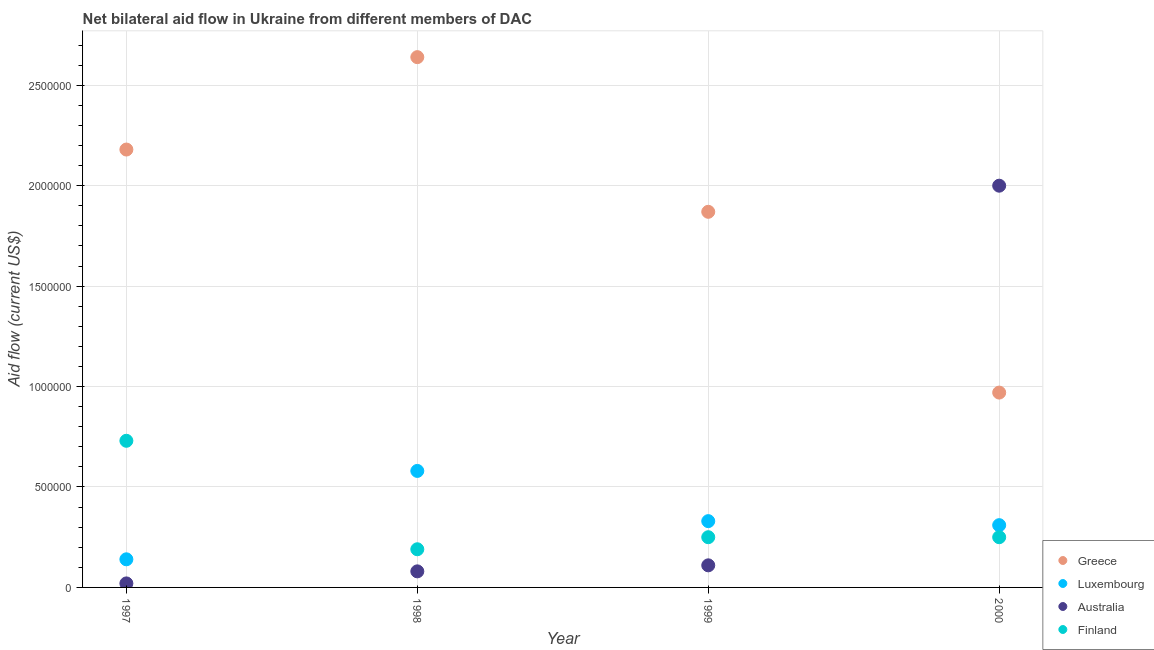Is the number of dotlines equal to the number of legend labels?
Provide a succinct answer. Yes. What is the amount of aid given by finland in 1999?
Provide a succinct answer. 2.50e+05. Across all years, what is the maximum amount of aid given by luxembourg?
Provide a succinct answer. 5.80e+05. Across all years, what is the minimum amount of aid given by luxembourg?
Keep it short and to the point. 1.40e+05. In which year was the amount of aid given by luxembourg minimum?
Offer a terse response. 1997. What is the total amount of aid given by finland in the graph?
Keep it short and to the point. 1.42e+06. What is the difference between the amount of aid given by australia in 1997 and the amount of aid given by greece in 2000?
Offer a terse response. -9.50e+05. What is the average amount of aid given by greece per year?
Your answer should be very brief. 1.92e+06. In the year 1999, what is the difference between the amount of aid given by greece and amount of aid given by luxembourg?
Your answer should be compact. 1.54e+06. What is the ratio of the amount of aid given by greece in 1997 to that in 1998?
Your response must be concise. 0.83. Is the amount of aid given by australia in 1997 less than that in 2000?
Make the answer very short. Yes. Is the difference between the amount of aid given by luxembourg in 1997 and 2000 greater than the difference between the amount of aid given by greece in 1997 and 2000?
Ensure brevity in your answer.  No. What is the difference between the highest and the lowest amount of aid given by greece?
Provide a succinct answer. 1.67e+06. In how many years, is the amount of aid given by finland greater than the average amount of aid given by finland taken over all years?
Your response must be concise. 1. Does the amount of aid given by finland monotonically increase over the years?
Offer a terse response. No. Is the amount of aid given by australia strictly less than the amount of aid given by finland over the years?
Keep it short and to the point. No. How many dotlines are there?
Your response must be concise. 4. How many years are there in the graph?
Offer a very short reply. 4. What is the difference between two consecutive major ticks on the Y-axis?
Give a very brief answer. 5.00e+05. Does the graph contain grids?
Your answer should be compact. Yes. Where does the legend appear in the graph?
Ensure brevity in your answer.  Bottom right. What is the title of the graph?
Make the answer very short. Net bilateral aid flow in Ukraine from different members of DAC. What is the label or title of the X-axis?
Offer a terse response. Year. What is the Aid flow (current US$) of Greece in 1997?
Make the answer very short. 2.18e+06. What is the Aid flow (current US$) of Luxembourg in 1997?
Provide a short and direct response. 1.40e+05. What is the Aid flow (current US$) in Finland in 1997?
Provide a short and direct response. 7.30e+05. What is the Aid flow (current US$) of Greece in 1998?
Give a very brief answer. 2.64e+06. What is the Aid flow (current US$) of Luxembourg in 1998?
Provide a succinct answer. 5.80e+05. What is the Aid flow (current US$) of Greece in 1999?
Your response must be concise. 1.87e+06. What is the Aid flow (current US$) in Luxembourg in 1999?
Provide a short and direct response. 3.30e+05. What is the Aid flow (current US$) in Australia in 1999?
Your response must be concise. 1.10e+05. What is the Aid flow (current US$) of Finland in 1999?
Give a very brief answer. 2.50e+05. What is the Aid flow (current US$) of Greece in 2000?
Your response must be concise. 9.70e+05. What is the Aid flow (current US$) of Australia in 2000?
Your response must be concise. 2.00e+06. Across all years, what is the maximum Aid flow (current US$) of Greece?
Offer a very short reply. 2.64e+06. Across all years, what is the maximum Aid flow (current US$) in Luxembourg?
Provide a short and direct response. 5.80e+05. Across all years, what is the maximum Aid flow (current US$) of Finland?
Your answer should be very brief. 7.30e+05. Across all years, what is the minimum Aid flow (current US$) of Greece?
Keep it short and to the point. 9.70e+05. What is the total Aid flow (current US$) in Greece in the graph?
Your response must be concise. 7.66e+06. What is the total Aid flow (current US$) of Luxembourg in the graph?
Provide a succinct answer. 1.36e+06. What is the total Aid flow (current US$) in Australia in the graph?
Offer a terse response. 2.21e+06. What is the total Aid flow (current US$) in Finland in the graph?
Make the answer very short. 1.42e+06. What is the difference between the Aid flow (current US$) of Greece in 1997 and that in 1998?
Make the answer very short. -4.60e+05. What is the difference between the Aid flow (current US$) of Luxembourg in 1997 and that in 1998?
Make the answer very short. -4.40e+05. What is the difference between the Aid flow (current US$) in Australia in 1997 and that in 1998?
Ensure brevity in your answer.  -6.00e+04. What is the difference between the Aid flow (current US$) in Finland in 1997 and that in 1998?
Your answer should be compact. 5.40e+05. What is the difference between the Aid flow (current US$) of Greece in 1997 and that in 1999?
Offer a very short reply. 3.10e+05. What is the difference between the Aid flow (current US$) in Luxembourg in 1997 and that in 1999?
Make the answer very short. -1.90e+05. What is the difference between the Aid flow (current US$) in Greece in 1997 and that in 2000?
Provide a short and direct response. 1.21e+06. What is the difference between the Aid flow (current US$) in Luxembourg in 1997 and that in 2000?
Offer a terse response. -1.70e+05. What is the difference between the Aid flow (current US$) of Australia in 1997 and that in 2000?
Your answer should be very brief. -1.98e+06. What is the difference between the Aid flow (current US$) of Finland in 1997 and that in 2000?
Give a very brief answer. 4.80e+05. What is the difference between the Aid flow (current US$) of Greece in 1998 and that in 1999?
Provide a short and direct response. 7.70e+05. What is the difference between the Aid flow (current US$) of Luxembourg in 1998 and that in 1999?
Your answer should be very brief. 2.50e+05. What is the difference between the Aid flow (current US$) of Australia in 1998 and that in 1999?
Your response must be concise. -3.00e+04. What is the difference between the Aid flow (current US$) in Greece in 1998 and that in 2000?
Offer a very short reply. 1.67e+06. What is the difference between the Aid flow (current US$) of Luxembourg in 1998 and that in 2000?
Your response must be concise. 2.70e+05. What is the difference between the Aid flow (current US$) of Australia in 1998 and that in 2000?
Keep it short and to the point. -1.92e+06. What is the difference between the Aid flow (current US$) in Greece in 1999 and that in 2000?
Provide a succinct answer. 9.00e+05. What is the difference between the Aid flow (current US$) in Australia in 1999 and that in 2000?
Make the answer very short. -1.89e+06. What is the difference between the Aid flow (current US$) in Greece in 1997 and the Aid flow (current US$) in Luxembourg in 1998?
Provide a short and direct response. 1.60e+06. What is the difference between the Aid flow (current US$) in Greece in 1997 and the Aid flow (current US$) in Australia in 1998?
Your answer should be very brief. 2.10e+06. What is the difference between the Aid flow (current US$) of Greece in 1997 and the Aid flow (current US$) of Finland in 1998?
Your answer should be very brief. 1.99e+06. What is the difference between the Aid flow (current US$) of Luxembourg in 1997 and the Aid flow (current US$) of Finland in 1998?
Provide a succinct answer. -5.00e+04. What is the difference between the Aid flow (current US$) of Australia in 1997 and the Aid flow (current US$) of Finland in 1998?
Your answer should be very brief. -1.70e+05. What is the difference between the Aid flow (current US$) of Greece in 1997 and the Aid flow (current US$) of Luxembourg in 1999?
Offer a terse response. 1.85e+06. What is the difference between the Aid flow (current US$) of Greece in 1997 and the Aid flow (current US$) of Australia in 1999?
Your answer should be compact. 2.07e+06. What is the difference between the Aid flow (current US$) of Greece in 1997 and the Aid flow (current US$) of Finland in 1999?
Provide a succinct answer. 1.93e+06. What is the difference between the Aid flow (current US$) of Luxembourg in 1997 and the Aid flow (current US$) of Finland in 1999?
Offer a very short reply. -1.10e+05. What is the difference between the Aid flow (current US$) in Australia in 1997 and the Aid flow (current US$) in Finland in 1999?
Offer a terse response. -2.30e+05. What is the difference between the Aid flow (current US$) of Greece in 1997 and the Aid flow (current US$) of Luxembourg in 2000?
Provide a succinct answer. 1.87e+06. What is the difference between the Aid flow (current US$) in Greece in 1997 and the Aid flow (current US$) in Finland in 2000?
Make the answer very short. 1.93e+06. What is the difference between the Aid flow (current US$) of Luxembourg in 1997 and the Aid flow (current US$) of Australia in 2000?
Offer a very short reply. -1.86e+06. What is the difference between the Aid flow (current US$) of Greece in 1998 and the Aid flow (current US$) of Luxembourg in 1999?
Make the answer very short. 2.31e+06. What is the difference between the Aid flow (current US$) in Greece in 1998 and the Aid flow (current US$) in Australia in 1999?
Your answer should be very brief. 2.53e+06. What is the difference between the Aid flow (current US$) in Greece in 1998 and the Aid flow (current US$) in Finland in 1999?
Offer a very short reply. 2.39e+06. What is the difference between the Aid flow (current US$) in Luxembourg in 1998 and the Aid flow (current US$) in Finland in 1999?
Your answer should be very brief. 3.30e+05. What is the difference between the Aid flow (current US$) of Australia in 1998 and the Aid flow (current US$) of Finland in 1999?
Offer a terse response. -1.70e+05. What is the difference between the Aid flow (current US$) in Greece in 1998 and the Aid flow (current US$) in Luxembourg in 2000?
Your response must be concise. 2.33e+06. What is the difference between the Aid flow (current US$) of Greece in 1998 and the Aid flow (current US$) of Australia in 2000?
Provide a succinct answer. 6.40e+05. What is the difference between the Aid flow (current US$) in Greece in 1998 and the Aid flow (current US$) in Finland in 2000?
Keep it short and to the point. 2.39e+06. What is the difference between the Aid flow (current US$) in Luxembourg in 1998 and the Aid flow (current US$) in Australia in 2000?
Ensure brevity in your answer.  -1.42e+06. What is the difference between the Aid flow (current US$) in Luxembourg in 1998 and the Aid flow (current US$) in Finland in 2000?
Offer a very short reply. 3.30e+05. What is the difference between the Aid flow (current US$) of Australia in 1998 and the Aid flow (current US$) of Finland in 2000?
Give a very brief answer. -1.70e+05. What is the difference between the Aid flow (current US$) in Greece in 1999 and the Aid flow (current US$) in Luxembourg in 2000?
Your answer should be very brief. 1.56e+06. What is the difference between the Aid flow (current US$) in Greece in 1999 and the Aid flow (current US$) in Australia in 2000?
Give a very brief answer. -1.30e+05. What is the difference between the Aid flow (current US$) of Greece in 1999 and the Aid flow (current US$) of Finland in 2000?
Keep it short and to the point. 1.62e+06. What is the difference between the Aid flow (current US$) in Luxembourg in 1999 and the Aid flow (current US$) in Australia in 2000?
Ensure brevity in your answer.  -1.67e+06. What is the difference between the Aid flow (current US$) of Luxembourg in 1999 and the Aid flow (current US$) of Finland in 2000?
Provide a succinct answer. 8.00e+04. What is the difference between the Aid flow (current US$) of Australia in 1999 and the Aid flow (current US$) of Finland in 2000?
Your answer should be very brief. -1.40e+05. What is the average Aid flow (current US$) of Greece per year?
Ensure brevity in your answer.  1.92e+06. What is the average Aid flow (current US$) in Luxembourg per year?
Make the answer very short. 3.40e+05. What is the average Aid flow (current US$) in Australia per year?
Your answer should be very brief. 5.52e+05. What is the average Aid flow (current US$) in Finland per year?
Provide a succinct answer. 3.55e+05. In the year 1997, what is the difference between the Aid flow (current US$) in Greece and Aid flow (current US$) in Luxembourg?
Ensure brevity in your answer.  2.04e+06. In the year 1997, what is the difference between the Aid flow (current US$) of Greece and Aid flow (current US$) of Australia?
Make the answer very short. 2.16e+06. In the year 1997, what is the difference between the Aid flow (current US$) of Greece and Aid flow (current US$) of Finland?
Give a very brief answer. 1.45e+06. In the year 1997, what is the difference between the Aid flow (current US$) of Luxembourg and Aid flow (current US$) of Finland?
Offer a very short reply. -5.90e+05. In the year 1997, what is the difference between the Aid flow (current US$) of Australia and Aid flow (current US$) of Finland?
Provide a succinct answer. -7.10e+05. In the year 1998, what is the difference between the Aid flow (current US$) of Greece and Aid flow (current US$) of Luxembourg?
Make the answer very short. 2.06e+06. In the year 1998, what is the difference between the Aid flow (current US$) in Greece and Aid flow (current US$) in Australia?
Your response must be concise. 2.56e+06. In the year 1998, what is the difference between the Aid flow (current US$) of Greece and Aid flow (current US$) of Finland?
Give a very brief answer. 2.45e+06. In the year 1998, what is the difference between the Aid flow (current US$) of Luxembourg and Aid flow (current US$) of Australia?
Offer a very short reply. 5.00e+05. In the year 1998, what is the difference between the Aid flow (current US$) of Australia and Aid flow (current US$) of Finland?
Offer a very short reply. -1.10e+05. In the year 1999, what is the difference between the Aid flow (current US$) in Greece and Aid flow (current US$) in Luxembourg?
Provide a succinct answer. 1.54e+06. In the year 1999, what is the difference between the Aid flow (current US$) of Greece and Aid flow (current US$) of Australia?
Your response must be concise. 1.76e+06. In the year 1999, what is the difference between the Aid flow (current US$) in Greece and Aid flow (current US$) in Finland?
Ensure brevity in your answer.  1.62e+06. In the year 1999, what is the difference between the Aid flow (current US$) of Australia and Aid flow (current US$) of Finland?
Your response must be concise. -1.40e+05. In the year 2000, what is the difference between the Aid flow (current US$) of Greece and Aid flow (current US$) of Australia?
Your response must be concise. -1.03e+06. In the year 2000, what is the difference between the Aid flow (current US$) of Greece and Aid flow (current US$) of Finland?
Make the answer very short. 7.20e+05. In the year 2000, what is the difference between the Aid flow (current US$) in Luxembourg and Aid flow (current US$) in Australia?
Offer a very short reply. -1.69e+06. In the year 2000, what is the difference between the Aid flow (current US$) of Australia and Aid flow (current US$) of Finland?
Provide a succinct answer. 1.75e+06. What is the ratio of the Aid flow (current US$) in Greece in 1997 to that in 1998?
Provide a short and direct response. 0.83. What is the ratio of the Aid flow (current US$) in Luxembourg in 1997 to that in 1998?
Keep it short and to the point. 0.24. What is the ratio of the Aid flow (current US$) in Australia in 1997 to that in 1998?
Give a very brief answer. 0.25. What is the ratio of the Aid flow (current US$) of Finland in 1997 to that in 1998?
Keep it short and to the point. 3.84. What is the ratio of the Aid flow (current US$) of Greece in 1997 to that in 1999?
Offer a very short reply. 1.17. What is the ratio of the Aid flow (current US$) of Luxembourg in 1997 to that in 1999?
Make the answer very short. 0.42. What is the ratio of the Aid flow (current US$) in Australia in 1997 to that in 1999?
Keep it short and to the point. 0.18. What is the ratio of the Aid flow (current US$) of Finland in 1997 to that in 1999?
Your response must be concise. 2.92. What is the ratio of the Aid flow (current US$) in Greece in 1997 to that in 2000?
Ensure brevity in your answer.  2.25. What is the ratio of the Aid flow (current US$) of Luxembourg in 1997 to that in 2000?
Your response must be concise. 0.45. What is the ratio of the Aid flow (current US$) of Finland in 1997 to that in 2000?
Ensure brevity in your answer.  2.92. What is the ratio of the Aid flow (current US$) in Greece in 1998 to that in 1999?
Give a very brief answer. 1.41. What is the ratio of the Aid flow (current US$) in Luxembourg in 1998 to that in 1999?
Your answer should be very brief. 1.76. What is the ratio of the Aid flow (current US$) of Australia in 1998 to that in 1999?
Your answer should be very brief. 0.73. What is the ratio of the Aid flow (current US$) in Finland in 1998 to that in 1999?
Give a very brief answer. 0.76. What is the ratio of the Aid flow (current US$) in Greece in 1998 to that in 2000?
Ensure brevity in your answer.  2.72. What is the ratio of the Aid flow (current US$) in Luxembourg in 1998 to that in 2000?
Your answer should be very brief. 1.87. What is the ratio of the Aid flow (current US$) of Australia in 1998 to that in 2000?
Make the answer very short. 0.04. What is the ratio of the Aid flow (current US$) of Finland in 1998 to that in 2000?
Offer a very short reply. 0.76. What is the ratio of the Aid flow (current US$) of Greece in 1999 to that in 2000?
Offer a very short reply. 1.93. What is the ratio of the Aid flow (current US$) in Luxembourg in 1999 to that in 2000?
Provide a short and direct response. 1.06. What is the ratio of the Aid flow (current US$) of Australia in 1999 to that in 2000?
Provide a short and direct response. 0.06. What is the ratio of the Aid flow (current US$) of Finland in 1999 to that in 2000?
Your response must be concise. 1. What is the difference between the highest and the second highest Aid flow (current US$) in Australia?
Ensure brevity in your answer.  1.89e+06. What is the difference between the highest and the lowest Aid flow (current US$) of Greece?
Offer a terse response. 1.67e+06. What is the difference between the highest and the lowest Aid flow (current US$) of Australia?
Your response must be concise. 1.98e+06. What is the difference between the highest and the lowest Aid flow (current US$) of Finland?
Provide a short and direct response. 5.40e+05. 